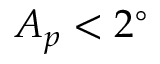<formula> <loc_0><loc_0><loc_500><loc_500>A _ { p } < 2 ^ { \circ }</formula> 